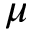<formula> <loc_0><loc_0><loc_500><loc_500>\mu</formula> 